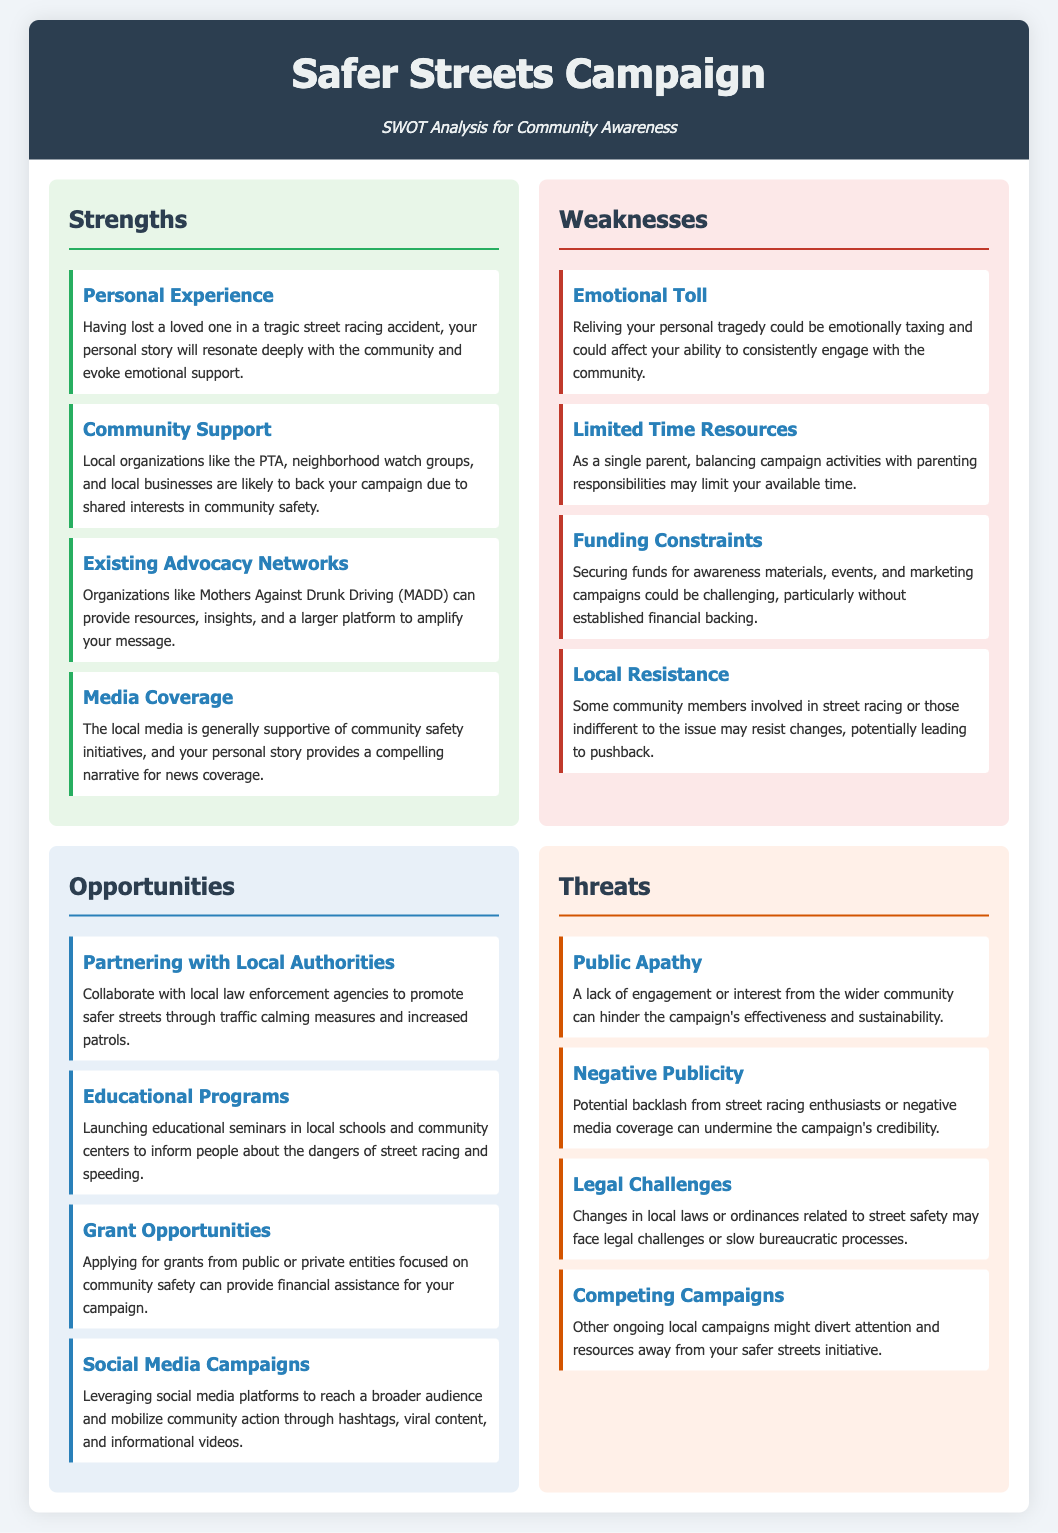what is the first strength listed in the SWOT analysis? The first strength listed is "Personal Experience," which highlights the impact of the advocate's personal story.
Answer: Personal Experience which organization can provide resources for the campaign? The document mentions "Mothers Against Drunk Driving (MADD)" as an organization that can assist the campaign.
Answer: MADD how many weaknesses are identified in the document? There are four weaknesses identified in the SWOT analysis of the campaign.
Answer: Four what is one opportunity listed for the campaign? The document lists "Partnering with Local Authorities" as an opportunity for collaboration to enhance street safety.
Answer: Partnering with Local Authorities what threat is associated with a lack of engagement from the community? The threat of "Public Apathy" is related to a lack of engagement from the community.
Answer: Public Apathy what type of campaigns can be leveraged to reach a broader audience? The document suggests using "Social Media Campaigns" to expand the reach of the initiative.
Answer: Social Media Campaigns which weakness involves emotional difficulty? The weakness titled "Emotional Toll" involves the emotional difficulty of reliving personal tragedy.
Answer: Emotional Toll how many threats are outlined in the analysis? There are four threats outlined in the SWOT analysis regarding the community awareness campaign.
Answer: Four what is a potential source of financial assistance mentioned in the opportunities? The document mentions "Grant Opportunities" as a source for financial assistance to support the campaign.
Answer: Grant Opportunities 